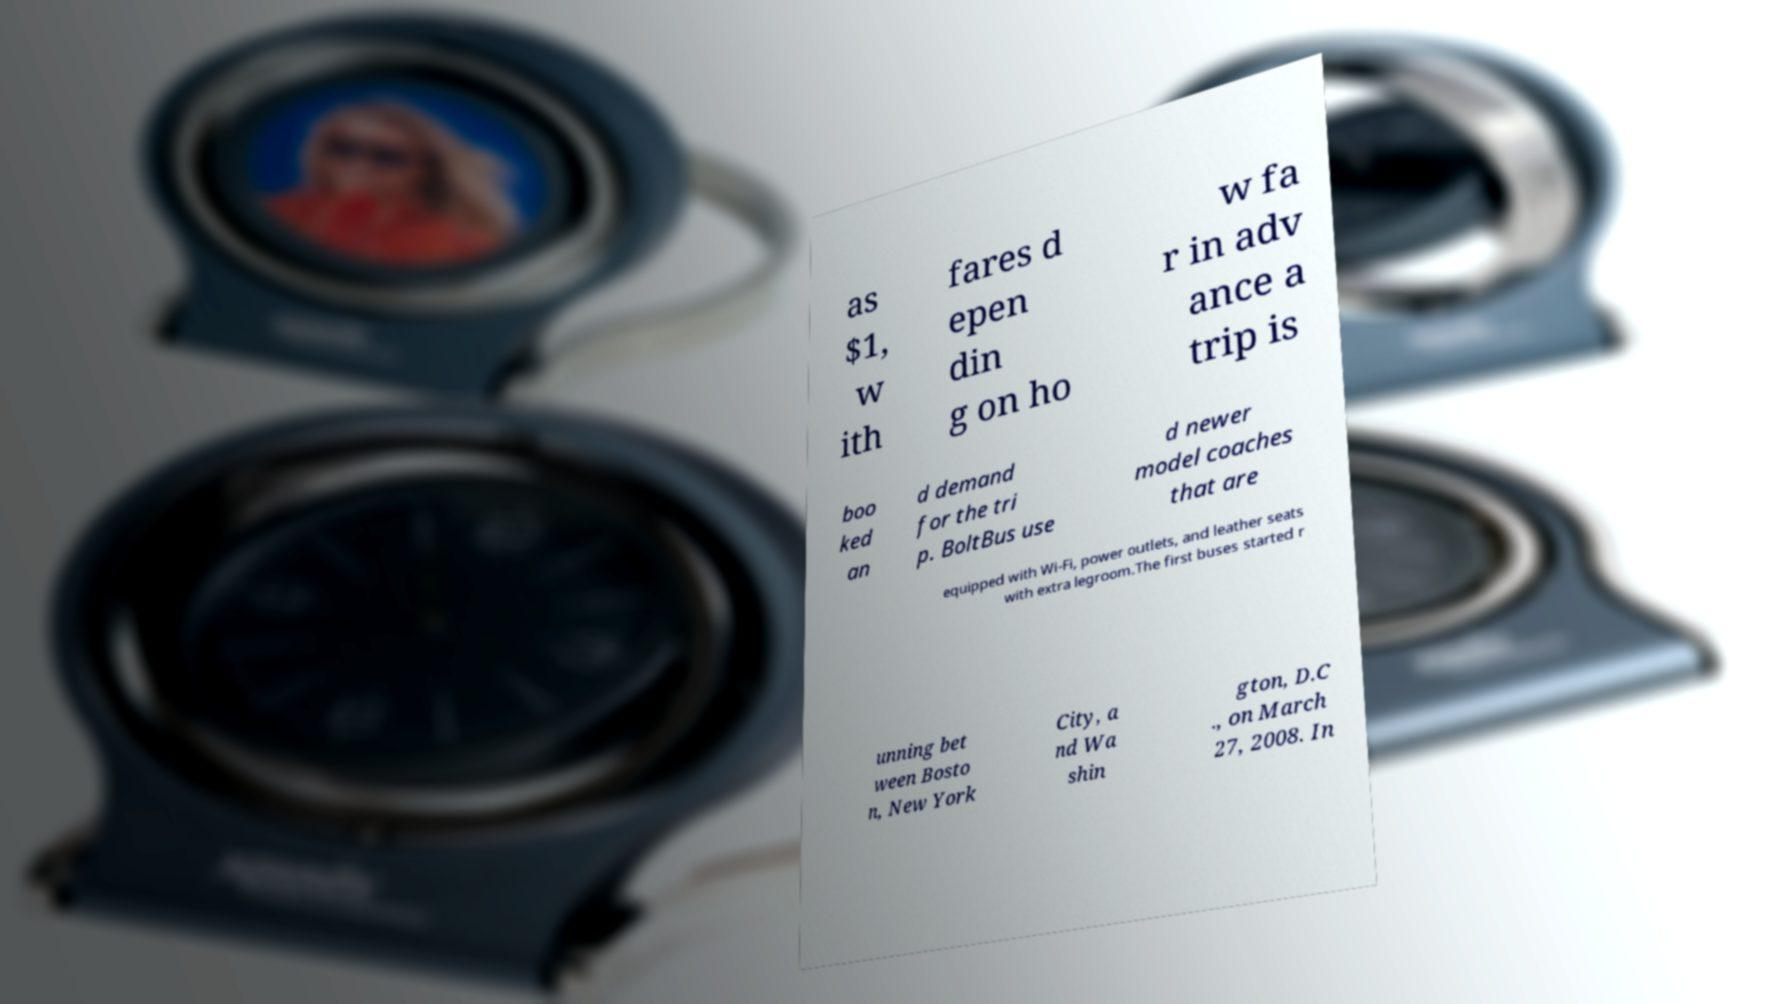Please identify and transcribe the text found in this image. as $1, w ith fares d epen din g on ho w fa r in adv ance a trip is boo ked an d demand for the tri p. BoltBus use d newer model coaches that are equipped with Wi-Fi, power outlets, and leather seats with extra legroom.The first buses started r unning bet ween Bosto n, New York City, a nd Wa shin gton, D.C ., on March 27, 2008. In 